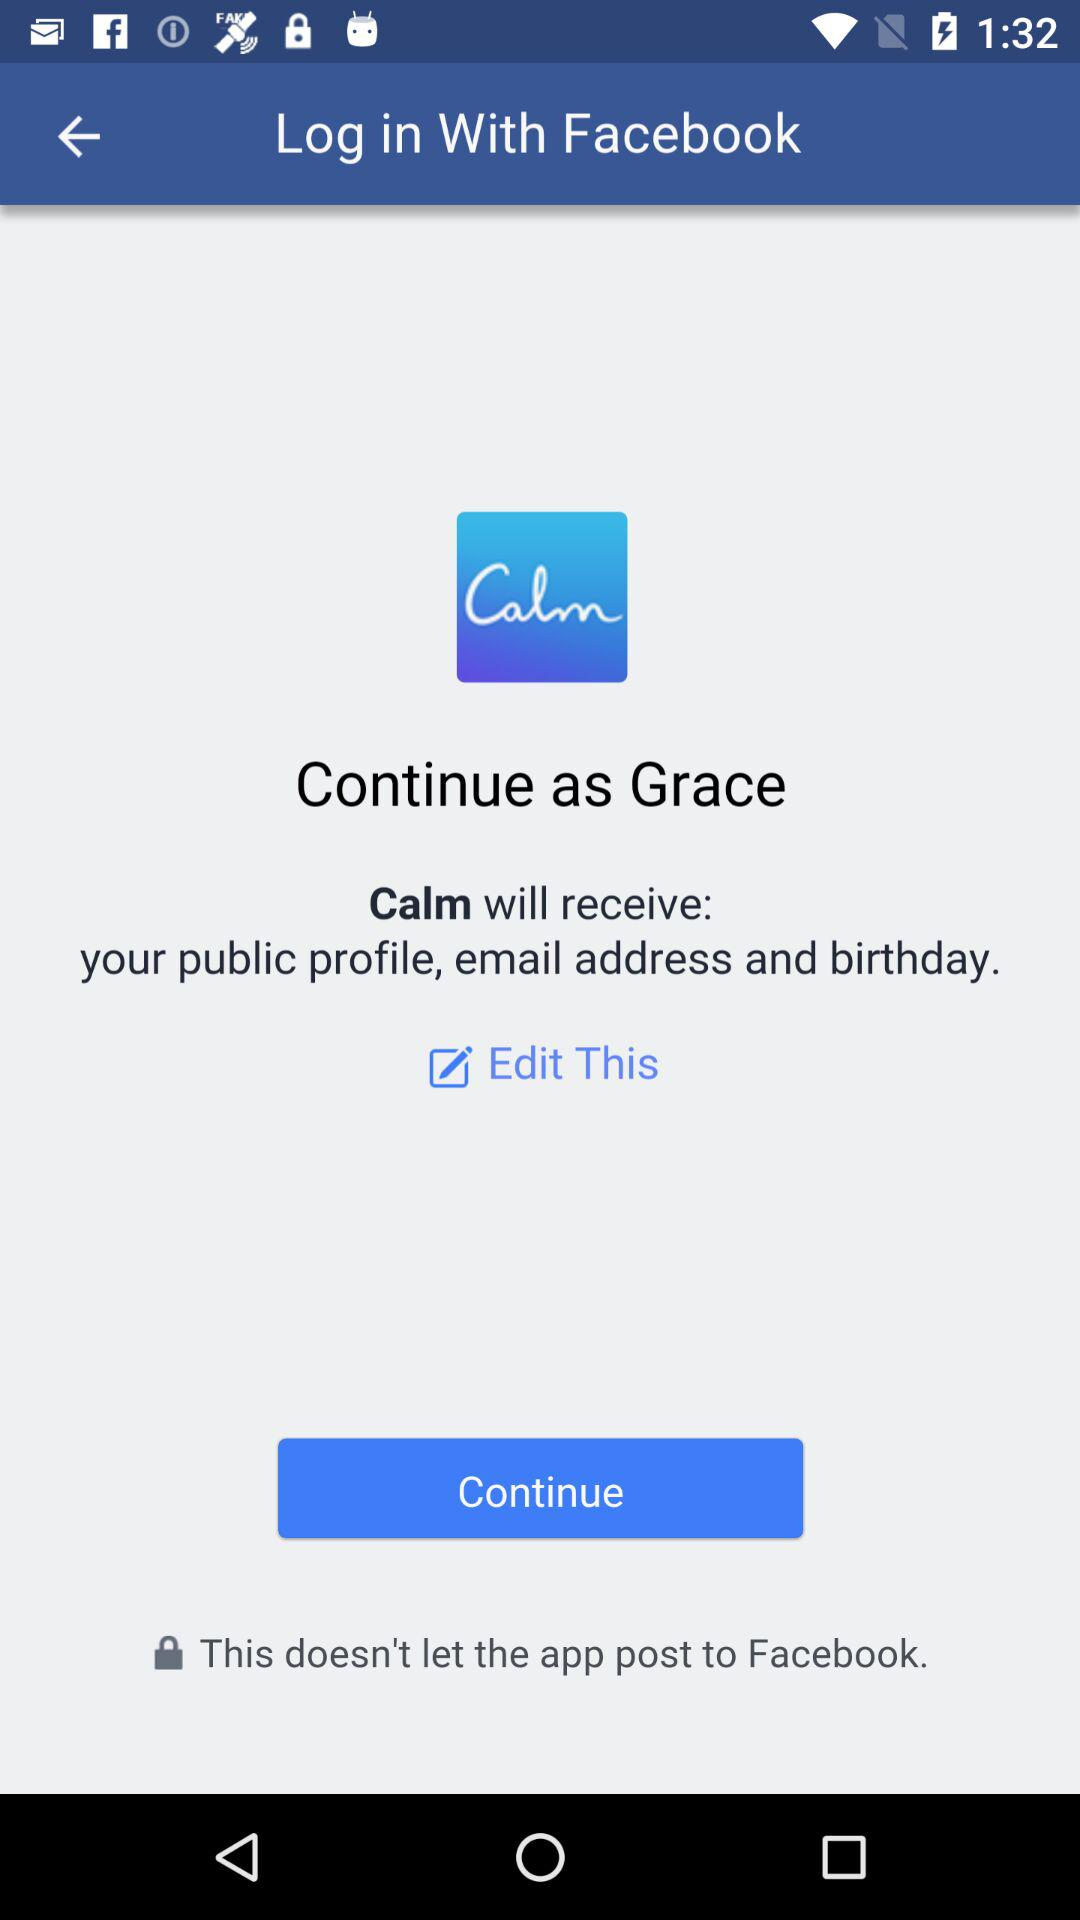Which application is being used to get access? The application that is being used to get access is "Facebook". 